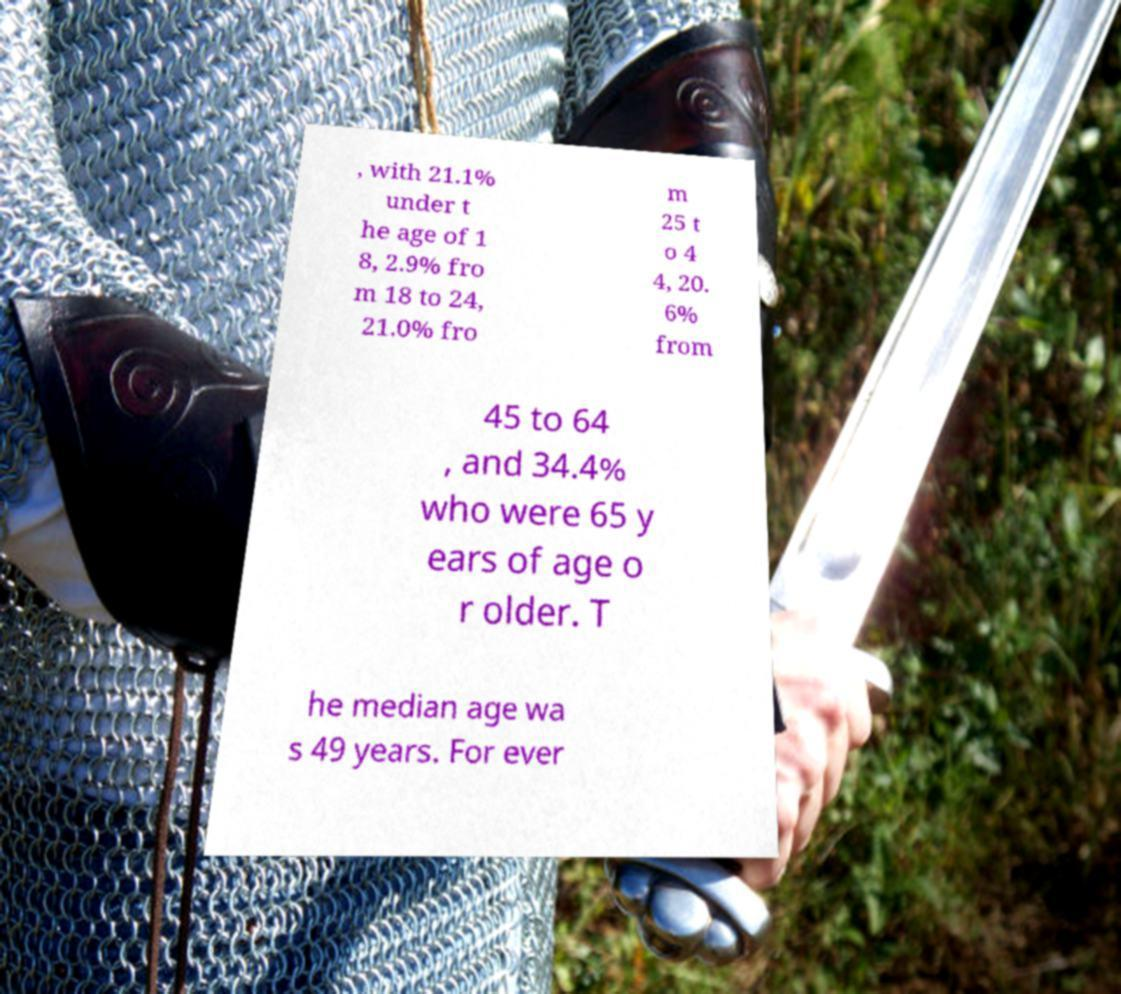There's text embedded in this image that I need extracted. Can you transcribe it verbatim? , with 21.1% under t he age of 1 8, 2.9% fro m 18 to 24, 21.0% fro m 25 t o 4 4, 20. 6% from 45 to 64 , and 34.4% who were 65 y ears of age o r older. T he median age wa s 49 years. For ever 